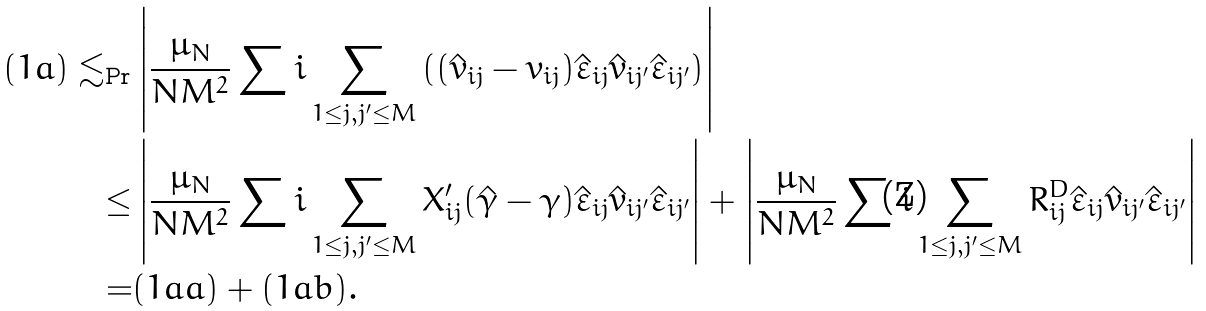Convert formula to latex. <formula><loc_0><loc_0><loc_500><loc_500>( 1 a ) \lesssim _ { \Pr } & \left | \frac { \mu _ { N } } { N M ^ { 2 } } \sum i \sum _ { 1 \leq j , j ^ { \prime } \leq M } \left ( ( \hat { v } _ { i j } - v _ { i j } ) \hat { \varepsilon } _ { i j } \hat { v } _ { i j ^ { \prime } } \hat { \varepsilon } _ { i j ^ { \prime } } \right ) \right | \\ \leq & \left | \frac { \mu _ { N } } { N M ^ { 2 } } \sum i \sum _ { 1 \leq j , j ^ { \prime } \leq M } X _ { i j } ^ { \prime } ( \hat { \gamma } - \gamma ) \hat { \varepsilon } _ { i j } \hat { v } _ { i j ^ { \prime } } \hat { \varepsilon } _ { i j ^ { \prime } } \right | + \left | \frac { \mu _ { N } } { N M ^ { 2 } } \sum i \sum _ { 1 \leq j , j ^ { \prime } \leq M } R ^ { D } _ { i j } \hat { \varepsilon } _ { i j } \hat { v } _ { i j ^ { \prime } } \hat { \varepsilon } _ { i j ^ { \prime } } \right | \\ = & ( 1 a a ) + ( 1 a b ) .</formula> 